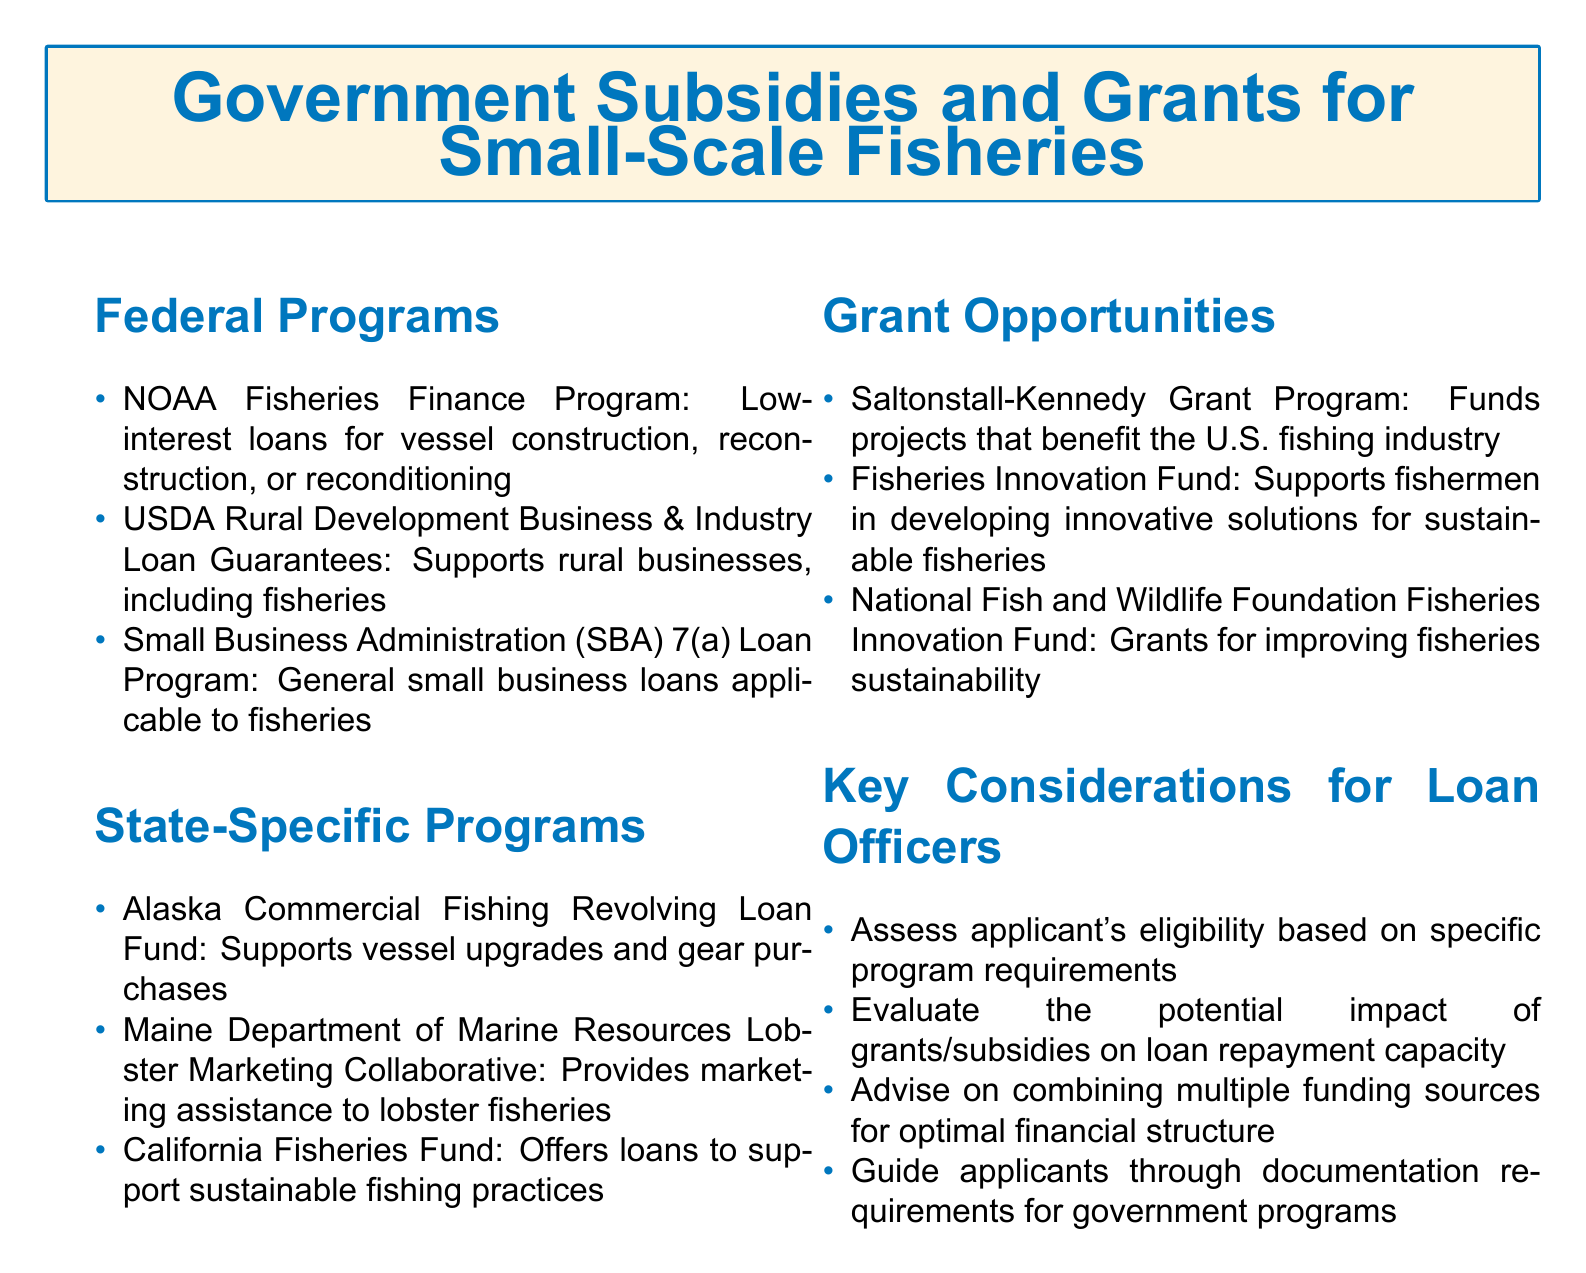What is the name of a federal program that offers low-interest loans? The document lists the NOAA Fisheries Finance Program as a federal program that provides low-interest loans for vessel construction, reconstruction, or reconditioning.
Answer: NOAA Fisheries Finance Program Which state-specific program supports vessel upgrades? The Alaska Commercial Fishing Revolving Loan Fund is mentioned as a program that supports vessel upgrades and gear purchases.
Answer: Alaska Commercial Fishing Revolving Loan Fund What type of assistance does the Maine Department of Marine Resources provide? The document states that the Maine Department of Marine Resources Lobster Marketing Collaborative provides marketing assistance to lobster fisheries.
Answer: Marketing assistance How many grant opportunities are listed in the document? There are three specific grant opportunities listed in the grant opportunities section of the document.
Answer: Three What is a key consideration for loan officers regarding applicants? The document mentions that loan officers should assess applicant's eligibility based on specific program requirements.
Answer: Assess eligibility What funding source supports sustainable fishing practices? The California Fisheries Fund is identified as a funding source that offers loans to support sustainable fishing practices.
Answer: California Fisheries Fund Name a program that funds projects benefiting the U.S. fishing industry. The Saltonstall-Kennedy Grant Program is noted as a program that funds projects benefiting the U.S. fishing industry.
Answer: Saltonstall-Kennedy Grant Program Which organization's fund focuses on fisheries sustainability? The National Fish and Wildlife Foundation's Fisheries Innovation Fund is mentioned as a source of grants for improving fisheries sustainability.
Answer: National Fish and Wildlife Foundation Fisheries Innovation Fund 